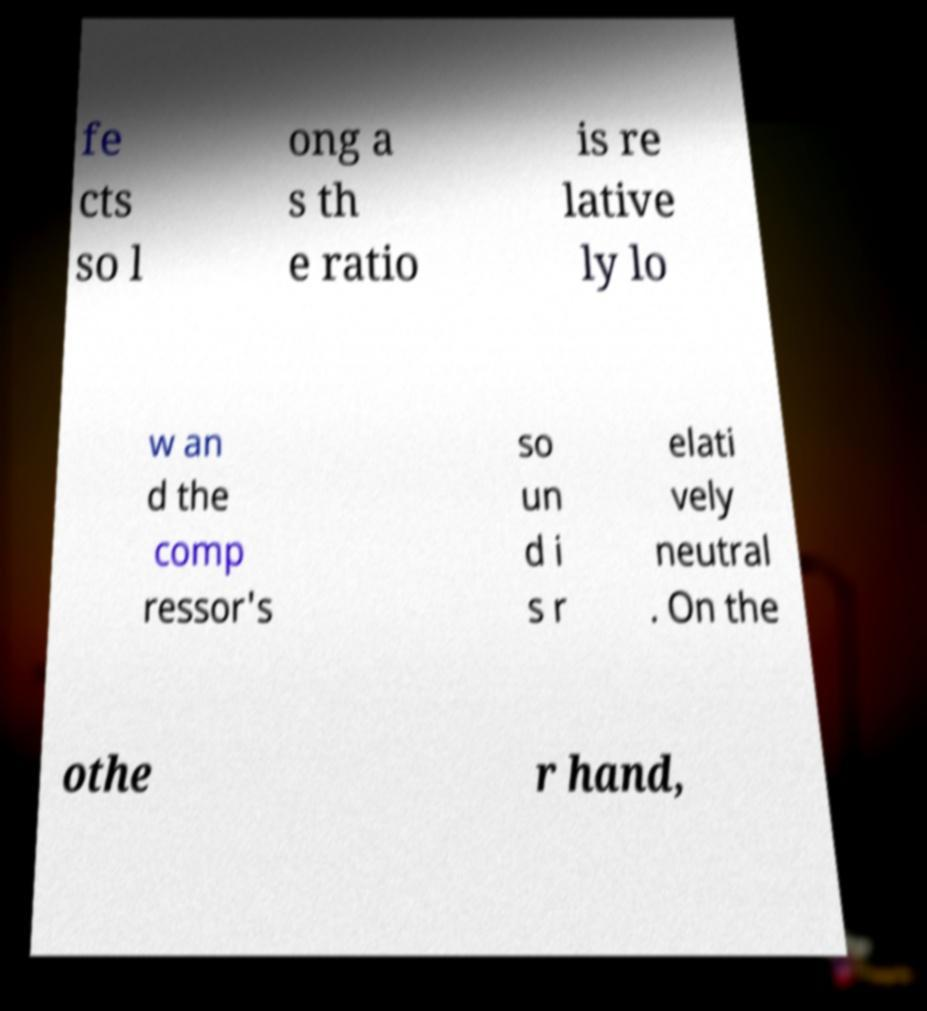For documentation purposes, I need the text within this image transcribed. Could you provide that? fe cts so l ong a s th e ratio is re lative ly lo w an d the comp ressor's so un d i s r elati vely neutral . On the othe r hand, 